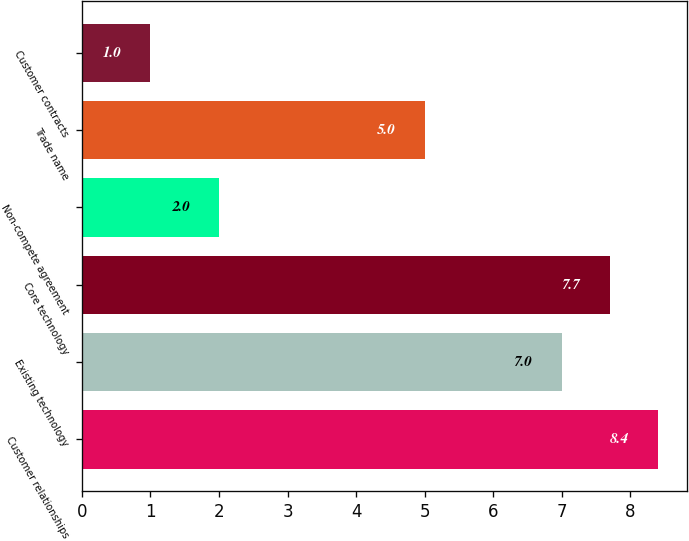Convert chart to OTSL. <chart><loc_0><loc_0><loc_500><loc_500><bar_chart><fcel>Customer relationships<fcel>Existing technology<fcel>Core technology<fcel>Non-compete agreement<fcel>Trade name<fcel>Customer contracts<nl><fcel>8.4<fcel>7<fcel>7.7<fcel>2<fcel>5<fcel>1<nl></chart> 